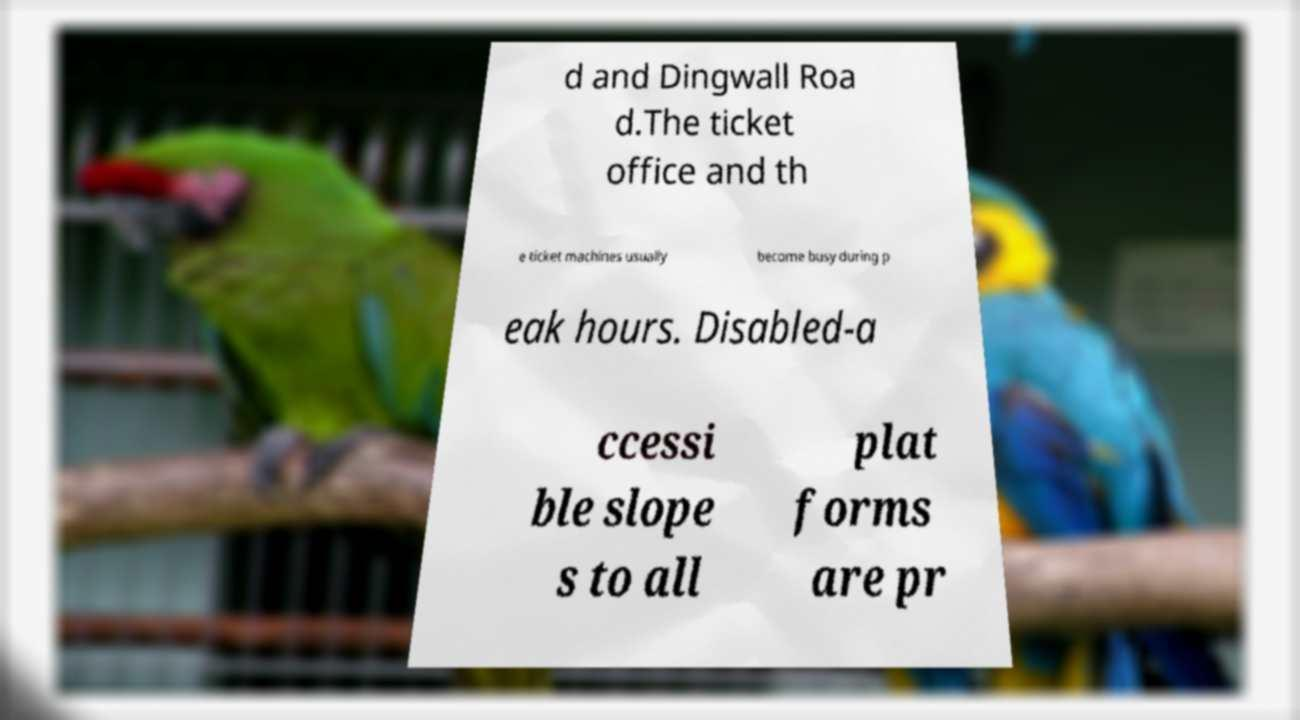What messages or text are displayed in this image? I need them in a readable, typed format. d and Dingwall Roa d.The ticket office and th e ticket machines usually become busy during p eak hours. Disabled-a ccessi ble slope s to all plat forms are pr 